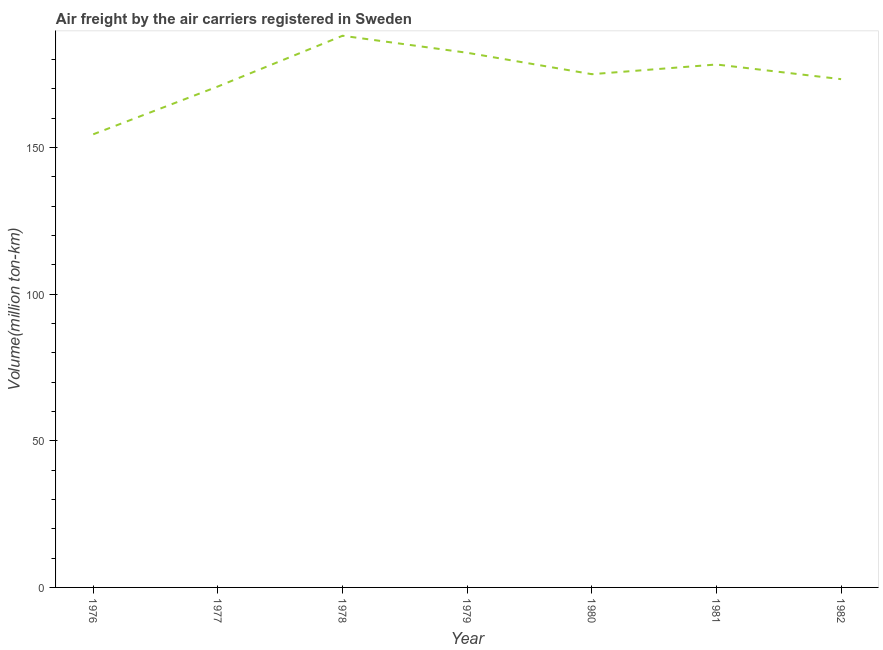What is the air freight in 1977?
Keep it short and to the point. 170.8. Across all years, what is the maximum air freight?
Your response must be concise. 188.1. Across all years, what is the minimum air freight?
Offer a terse response. 154.5. In which year was the air freight maximum?
Your response must be concise. 1978. In which year was the air freight minimum?
Make the answer very short. 1976. What is the sum of the air freight?
Ensure brevity in your answer.  1222.3. What is the difference between the air freight in 1976 and 1982?
Your answer should be very brief. -18.8. What is the average air freight per year?
Your response must be concise. 174.61. What is the median air freight?
Make the answer very short. 175. In how many years, is the air freight greater than 70 million ton-km?
Your answer should be very brief. 7. What is the ratio of the air freight in 1976 to that in 1981?
Your response must be concise. 0.87. Is the air freight in 1976 less than that in 1982?
Your answer should be compact. Yes. What is the difference between the highest and the second highest air freight?
Keep it short and to the point. 5.8. Is the sum of the air freight in 1977 and 1979 greater than the maximum air freight across all years?
Make the answer very short. Yes. What is the difference between the highest and the lowest air freight?
Offer a terse response. 33.6. How many years are there in the graph?
Your answer should be very brief. 7. What is the difference between two consecutive major ticks on the Y-axis?
Provide a short and direct response. 50. What is the title of the graph?
Your answer should be compact. Air freight by the air carriers registered in Sweden. What is the label or title of the Y-axis?
Your answer should be very brief. Volume(million ton-km). What is the Volume(million ton-km) of 1976?
Your answer should be compact. 154.5. What is the Volume(million ton-km) of 1977?
Give a very brief answer. 170.8. What is the Volume(million ton-km) of 1978?
Ensure brevity in your answer.  188.1. What is the Volume(million ton-km) of 1979?
Provide a short and direct response. 182.3. What is the Volume(million ton-km) in 1980?
Make the answer very short. 175. What is the Volume(million ton-km) of 1981?
Keep it short and to the point. 178.3. What is the Volume(million ton-km) of 1982?
Offer a very short reply. 173.3. What is the difference between the Volume(million ton-km) in 1976 and 1977?
Provide a short and direct response. -16.3. What is the difference between the Volume(million ton-km) in 1976 and 1978?
Provide a short and direct response. -33.6. What is the difference between the Volume(million ton-km) in 1976 and 1979?
Ensure brevity in your answer.  -27.8. What is the difference between the Volume(million ton-km) in 1976 and 1980?
Ensure brevity in your answer.  -20.5. What is the difference between the Volume(million ton-km) in 1976 and 1981?
Keep it short and to the point. -23.8. What is the difference between the Volume(million ton-km) in 1976 and 1982?
Ensure brevity in your answer.  -18.8. What is the difference between the Volume(million ton-km) in 1977 and 1978?
Give a very brief answer. -17.3. What is the difference between the Volume(million ton-km) in 1978 and 1979?
Offer a terse response. 5.8. What is the difference between the Volume(million ton-km) in 1978 and 1980?
Your response must be concise. 13.1. What is the difference between the Volume(million ton-km) in 1978 and 1981?
Your answer should be very brief. 9.8. What is the difference between the Volume(million ton-km) in 1978 and 1982?
Give a very brief answer. 14.8. What is the difference between the Volume(million ton-km) in 1979 and 1980?
Your answer should be compact. 7.3. What is the difference between the Volume(million ton-km) in 1979 and 1982?
Your answer should be very brief. 9. What is the difference between the Volume(million ton-km) in 1981 and 1982?
Your answer should be very brief. 5. What is the ratio of the Volume(million ton-km) in 1976 to that in 1977?
Your answer should be very brief. 0.91. What is the ratio of the Volume(million ton-km) in 1976 to that in 1978?
Your answer should be very brief. 0.82. What is the ratio of the Volume(million ton-km) in 1976 to that in 1979?
Provide a succinct answer. 0.85. What is the ratio of the Volume(million ton-km) in 1976 to that in 1980?
Provide a succinct answer. 0.88. What is the ratio of the Volume(million ton-km) in 1976 to that in 1981?
Your answer should be compact. 0.87. What is the ratio of the Volume(million ton-km) in 1976 to that in 1982?
Keep it short and to the point. 0.89. What is the ratio of the Volume(million ton-km) in 1977 to that in 1978?
Offer a terse response. 0.91. What is the ratio of the Volume(million ton-km) in 1977 to that in 1979?
Ensure brevity in your answer.  0.94. What is the ratio of the Volume(million ton-km) in 1977 to that in 1980?
Provide a short and direct response. 0.98. What is the ratio of the Volume(million ton-km) in 1977 to that in 1981?
Offer a terse response. 0.96. What is the ratio of the Volume(million ton-km) in 1978 to that in 1979?
Your answer should be compact. 1.03. What is the ratio of the Volume(million ton-km) in 1978 to that in 1980?
Your answer should be very brief. 1.07. What is the ratio of the Volume(million ton-km) in 1978 to that in 1981?
Provide a short and direct response. 1.05. What is the ratio of the Volume(million ton-km) in 1978 to that in 1982?
Your answer should be very brief. 1.08. What is the ratio of the Volume(million ton-km) in 1979 to that in 1980?
Provide a succinct answer. 1.04. What is the ratio of the Volume(million ton-km) in 1979 to that in 1982?
Your response must be concise. 1.05. What is the ratio of the Volume(million ton-km) in 1980 to that in 1982?
Your answer should be compact. 1.01. 